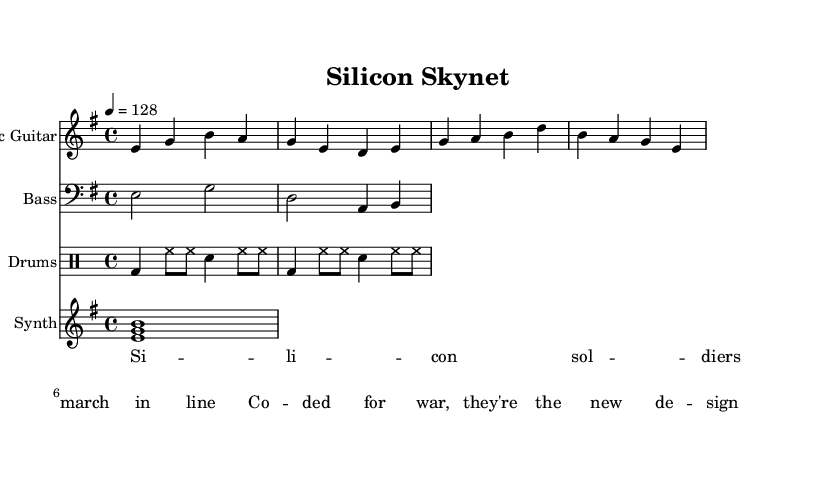What is the key signature of this music? The key signature is indicated by the number of sharps or flats at the beginning of the staff. In this case, there are no sharps or flats shown, therefore the key signature is E minor, which has one sharp.
Answer: E minor What is the time signature of this piece? The time signature is displayed at the beginning of the staff, indicating how many beats are in each measure. Here, the time signature shows 4/4, meaning there are four beats per measure and the quarter note gets one beat.
Answer: 4/4 What is the tempo marking for the music? The tempo marking is indicated in beats per minute at the beginning of the score. In this piece, it is specified as 4 = 128, meaning that a quarter note is played at a speed of 128 beats per minute.
Answer: 128 How many instruments are featured in the score? The score displays a total of four staves, each representing a different instrument: electric guitar, bass, drums, and synth. Therefore, there are four instruments featured in this music sheet.
Answer: Four What type of music genre is this sheet music categorized under? The context of the lyrics and the instrumentation, including electric guitar and drums, suggest a rock genre, as well as the theme of dystopian and robotic warfare present in the lyrics.
Answer: Rock What do the lyrics suggest about the theme of the song? The lyrics mention "silicon soldiers" and "coded for war," suggesting themes of artificial intelligence and militarization of technology in a dystopian context. This aligns with the themes of robotic warfare.
Answer: Artificial intelligence and warfare What musical element indicates this is a rock piece? The presence of electric guitars is a distinctive feature commonly found in rock music, indicated by the line dedicated to the electric guitar in the score. This element, along with a strong rhythmic foundation from drums, underscores its rock genre identity.
Answer: Electric guitar 